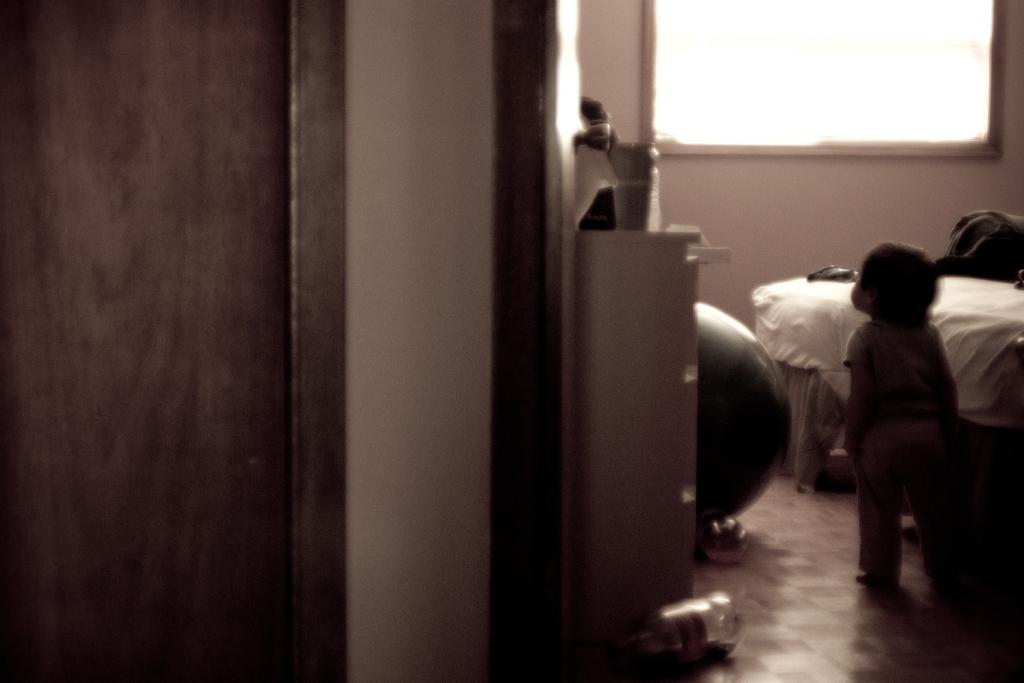Where was the image taken? The image was taken in a room. What can be seen on the right side of the door in the image? There is a baby standing on the right side of the door. What is in front of the baby in the image? There is a bed in front of the baby. What is visible on the wall in front of the bed? There is a window on the wall in front of the bed. What type of cloud can be seen in the baby's mouth in the image? There is no cloud visible in the baby's mouth in the image. How many boys are present in the image? The image does not depict any boys; it features a baby standing near a door. 